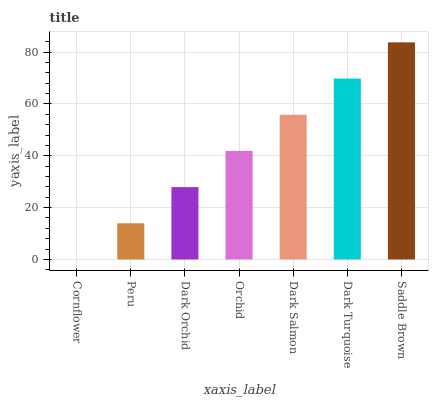Is Cornflower the minimum?
Answer yes or no. Yes. Is Saddle Brown the maximum?
Answer yes or no. Yes. Is Peru the minimum?
Answer yes or no. No. Is Peru the maximum?
Answer yes or no. No. Is Peru greater than Cornflower?
Answer yes or no. Yes. Is Cornflower less than Peru?
Answer yes or no. Yes. Is Cornflower greater than Peru?
Answer yes or no. No. Is Peru less than Cornflower?
Answer yes or no. No. Is Orchid the high median?
Answer yes or no. Yes. Is Orchid the low median?
Answer yes or no. Yes. Is Dark Salmon the high median?
Answer yes or no. No. Is Saddle Brown the low median?
Answer yes or no. No. 